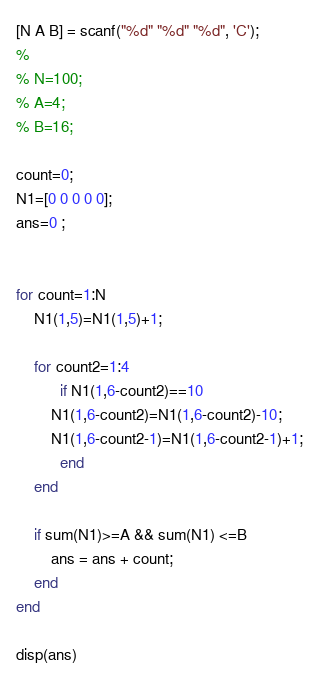<code> <loc_0><loc_0><loc_500><loc_500><_Octave_>[N A B] = scanf("%d" "%d" "%d", 'C');
% 
% N=100;
% A=4;
% B=16;

count=0;
N1=[0 0 0 0 0];
ans=0 ;


for count=1:N
    N1(1,5)=N1(1,5)+1;
    
    for count2=1:4
          if N1(1,6-count2)==10
        N1(1,6-count2)=N1(1,6-count2)-10;
        N1(1,6-count2-1)=N1(1,6-count2-1)+1;
          end
    end
    
    if sum(N1)>=A && sum(N1) <=B
        ans = ans + count;
    end
end

disp(ans)</code> 